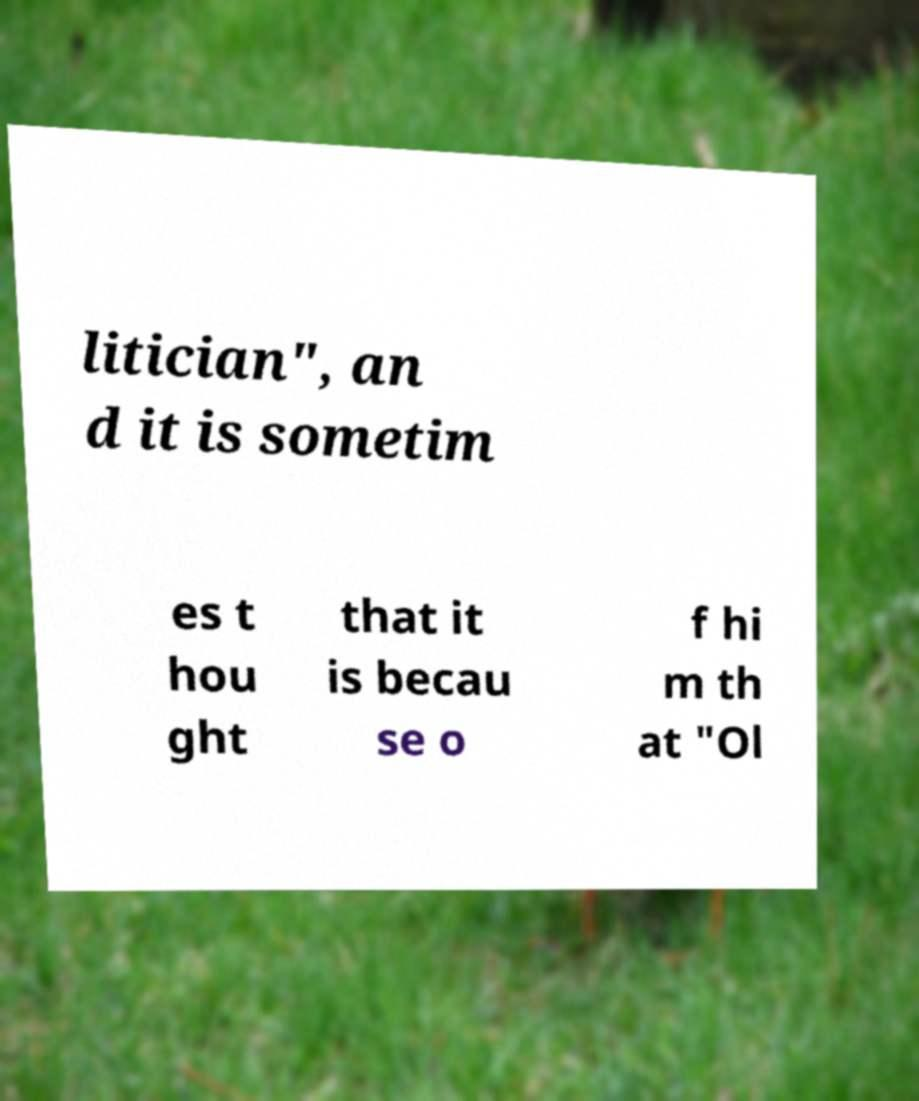I need the written content from this picture converted into text. Can you do that? litician", an d it is sometim es t hou ght that it is becau se o f hi m th at "Ol 